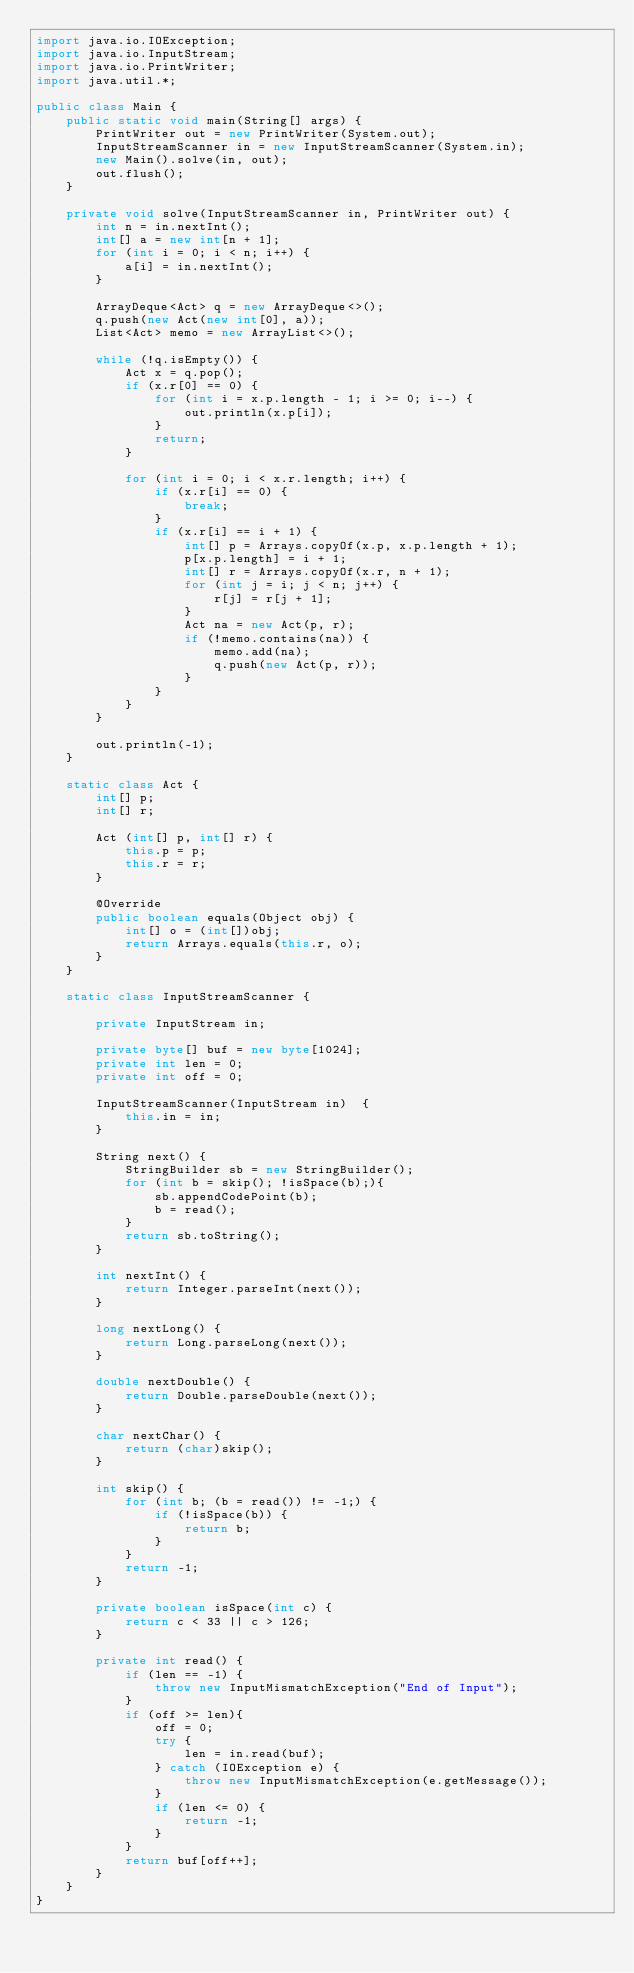Convert code to text. <code><loc_0><loc_0><loc_500><loc_500><_Java_>import java.io.IOException;
import java.io.InputStream;
import java.io.PrintWriter;
import java.util.*;

public class Main {
    public static void main(String[] args) {
        PrintWriter out = new PrintWriter(System.out);
        InputStreamScanner in = new InputStreamScanner(System.in);
        new Main().solve(in, out);
        out.flush();
    }

    private void solve(InputStreamScanner in, PrintWriter out) {
        int n = in.nextInt();
        int[] a = new int[n + 1];
        for (int i = 0; i < n; i++) {
            a[i] = in.nextInt();
        }

        ArrayDeque<Act> q = new ArrayDeque<>();
        q.push(new Act(new int[0], a));
        List<Act> memo = new ArrayList<>();

        while (!q.isEmpty()) {
            Act x = q.pop();
            if (x.r[0] == 0) {
                for (int i = x.p.length - 1; i >= 0; i--) {
                    out.println(x.p[i]);
                }
                return;
            }

            for (int i = 0; i < x.r.length; i++) {
                if (x.r[i] == 0) {
                    break;
                }
                if (x.r[i] == i + 1) {
                    int[] p = Arrays.copyOf(x.p, x.p.length + 1);
                    p[x.p.length] = i + 1;
                    int[] r = Arrays.copyOf(x.r, n + 1);
                    for (int j = i; j < n; j++) {
                        r[j] = r[j + 1];
                    }
                    Act na = new Act(p, r);
                    if (!memo.contains(na)) {
                        memo.add(na);
                        q.push(new Act(p, r));
                    }
                }
            }
        }

        out.println(-1);
    }

    static class Act {
        int[] p;
        int[] r;

        Act (int[] p, int[] r) {
            this.p = p;
            this.r = r;
        }

        @Override
        public boolean equals(Object obj) {
            int[] o = (int[])obj;
            return Arrays.equals(this.r, o);
        }
    }

    static class InputStreamScanner {

        private InputStream in;

        private byte[] buf = new byte[1024];
        private int len = 0;
        private int off = 0;

        InputStreamScanner(InputStream in)	{
            this.in = in;
        }

        String next() {
            StringBuilder sb = new StringBuilder();
            for (int b = skip(); !isSpace(b);){
                sb.appendCodePoint(b);
                b = read();
            }
            return sb.toString();
        }

        int nextInt() {
            return Integer.parseInt(next());
        }

        long nextLong() {
            return Long.parseLong(next());
        }

        double nextDouble() {
            return Double.parseDouble(next());
        }

        char nextChar() {
            return (char)skip();
        }

        int skip() {
            for (int b; (b = read()) != -1;) {
                if (!isSpace(b)) {
                    return b;
                }
            }
            return -1;
        }

        private boolean isSpace(int c) {
            return c < 33 || c > 126;
        }

        private int read() {
            if (len == -1) {
                throw new InputMismatchException("End of Input");
            }
            if (off >= len){
                off = 0;
                try {
                    len = in.read(buf);
                } catch (IOException e) {
                    throw new InputMismatchException(e.getMessage());
                }
                if (len <= 0) {
                    return -1;
                }
            }
            return buf[off++];
        }
    }
}</code> 